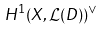Convert formula to latex. <formula><loc_0><loc_0><loc_500><loc_500>H ^ { 1 } ( X , { \mathcal { L } } ( D ) ) ^ { \vee }</formula> 